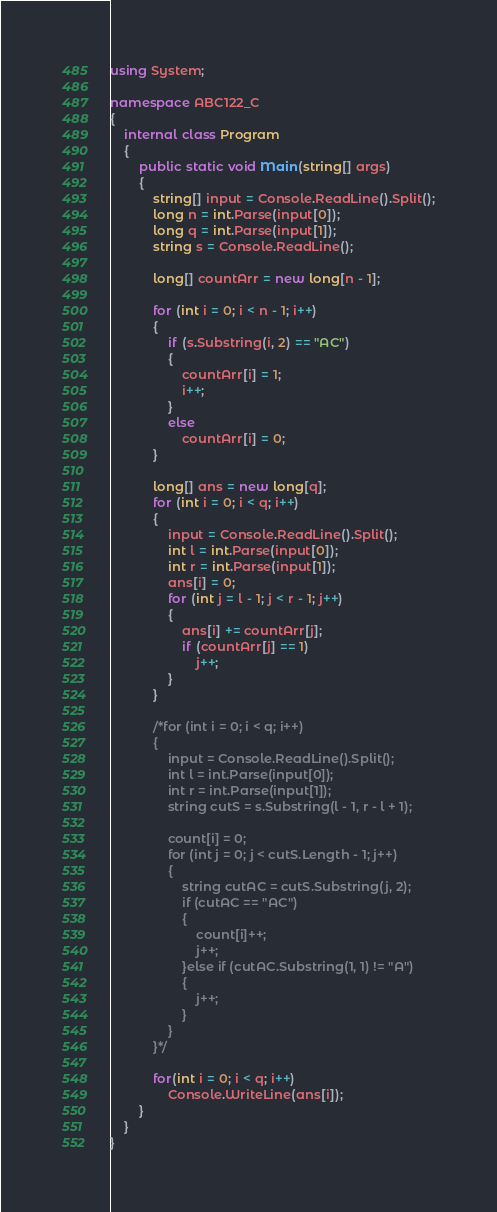<code> <loc_0><loc_0><loc_500><loc_500><_C#_>using System;

namespace ABC122_C
{
	internal class Program
	{
		public static void Main(string[] args)
		{
			string[] input = Console.ReadLine().Split();
			long n = int.Parse(input[0]);
			long q = int.Parse(input[1]);
			string s = Console.ReadLine();

			long[] countArr = new long[n - 1];

			for (int i = 0; i < n - 1; i++)
			{
				if (s.Substring(i, 2) == "AC")
				{
					countArr[i] = 1;
					i++;
				}	
				else
					countArr[i] = 0;
			}
			
			long[] ans = new long[q];
			for (int i = 0; i < q; i++)
			{
				input = Console.ReadLine().Split();
				int l = int.Parse(input[0]);
				int r = int.Parse(input[1]);
				ans[i] = 0;
				for (int j = l - 1; j < r - 1; j++)
				{
					ans[i] += countArr[j];
					if (countArr[j] == 1)
						j++;
				}
			}
			
			/*for (int i = 0; i < q; i++)
			{
				input = Console.ReadLine().Split();
				int l = int.Parse(input[0]);
				int r = int.Parse(input[1]);
				string cutS = s.Substring(l - 1, r - l + 1);

				count[i] = 0;
				for (int j = 0; j < cutS.Length - 1; j++)
				{
					string cutAC = cutS.Substring(j, 2);
					if (cutAC == "AC")
					{
						count[i]++;
						j++;
					}else if (cutAC.Substring(1, 1) != "A")
					{
						j++;
					}
				}
			}*/
			
			for(int i = 0; i < q; i++)
				Console.WriteLine(ans[i]);
		}
	}
}
</code> 